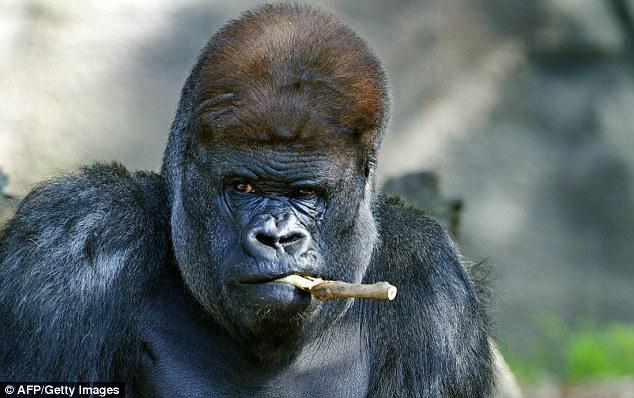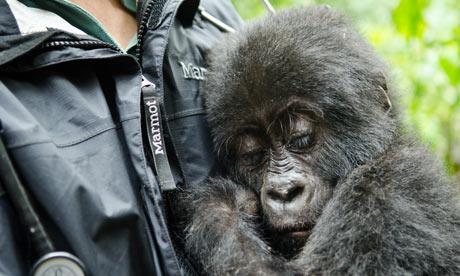The first image is the image on the left, the second image is the image on the right. Assess this claim about the two images: "An image shows at least one forward-facing gorilla with something stick-like in its mouth.". Correct or not? Answer yes or no. Yes. 